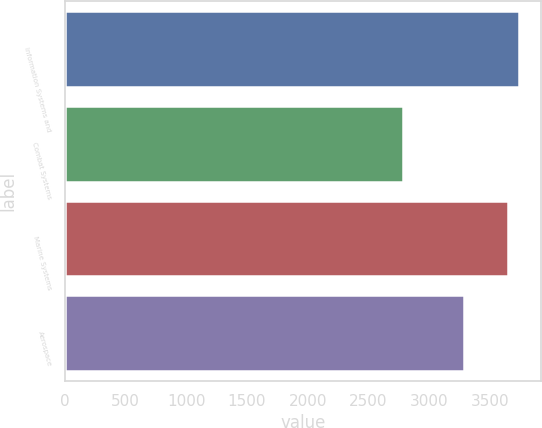Convert chart. <chart><loc_0><loc_0><loc_500><loc_500><bar_chart><fcel>Information Systems and<fcel>Combat Systems<fcel>Marine Systems<fcel>Aerospace<nl><fcel>3738.3<fcel>2786<fcel>3650<fcel>3289<nl></chart> 